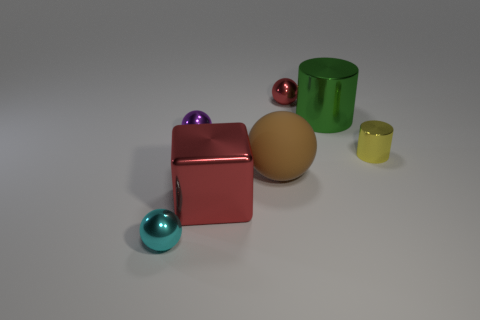How does the lighting affect the perception of the objects? The lighting creates soft shadows and subtle reflections on the objects, enhancing their three-dimensional appearance and highlighting the texture and color variations. 